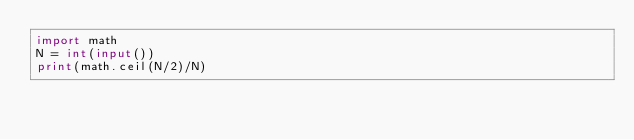<code> <loc_0><loc_0><loc_500><loc_500><_Python_>import math
N = int(input())
print(math.ceil(N/2)/N)
</code> 